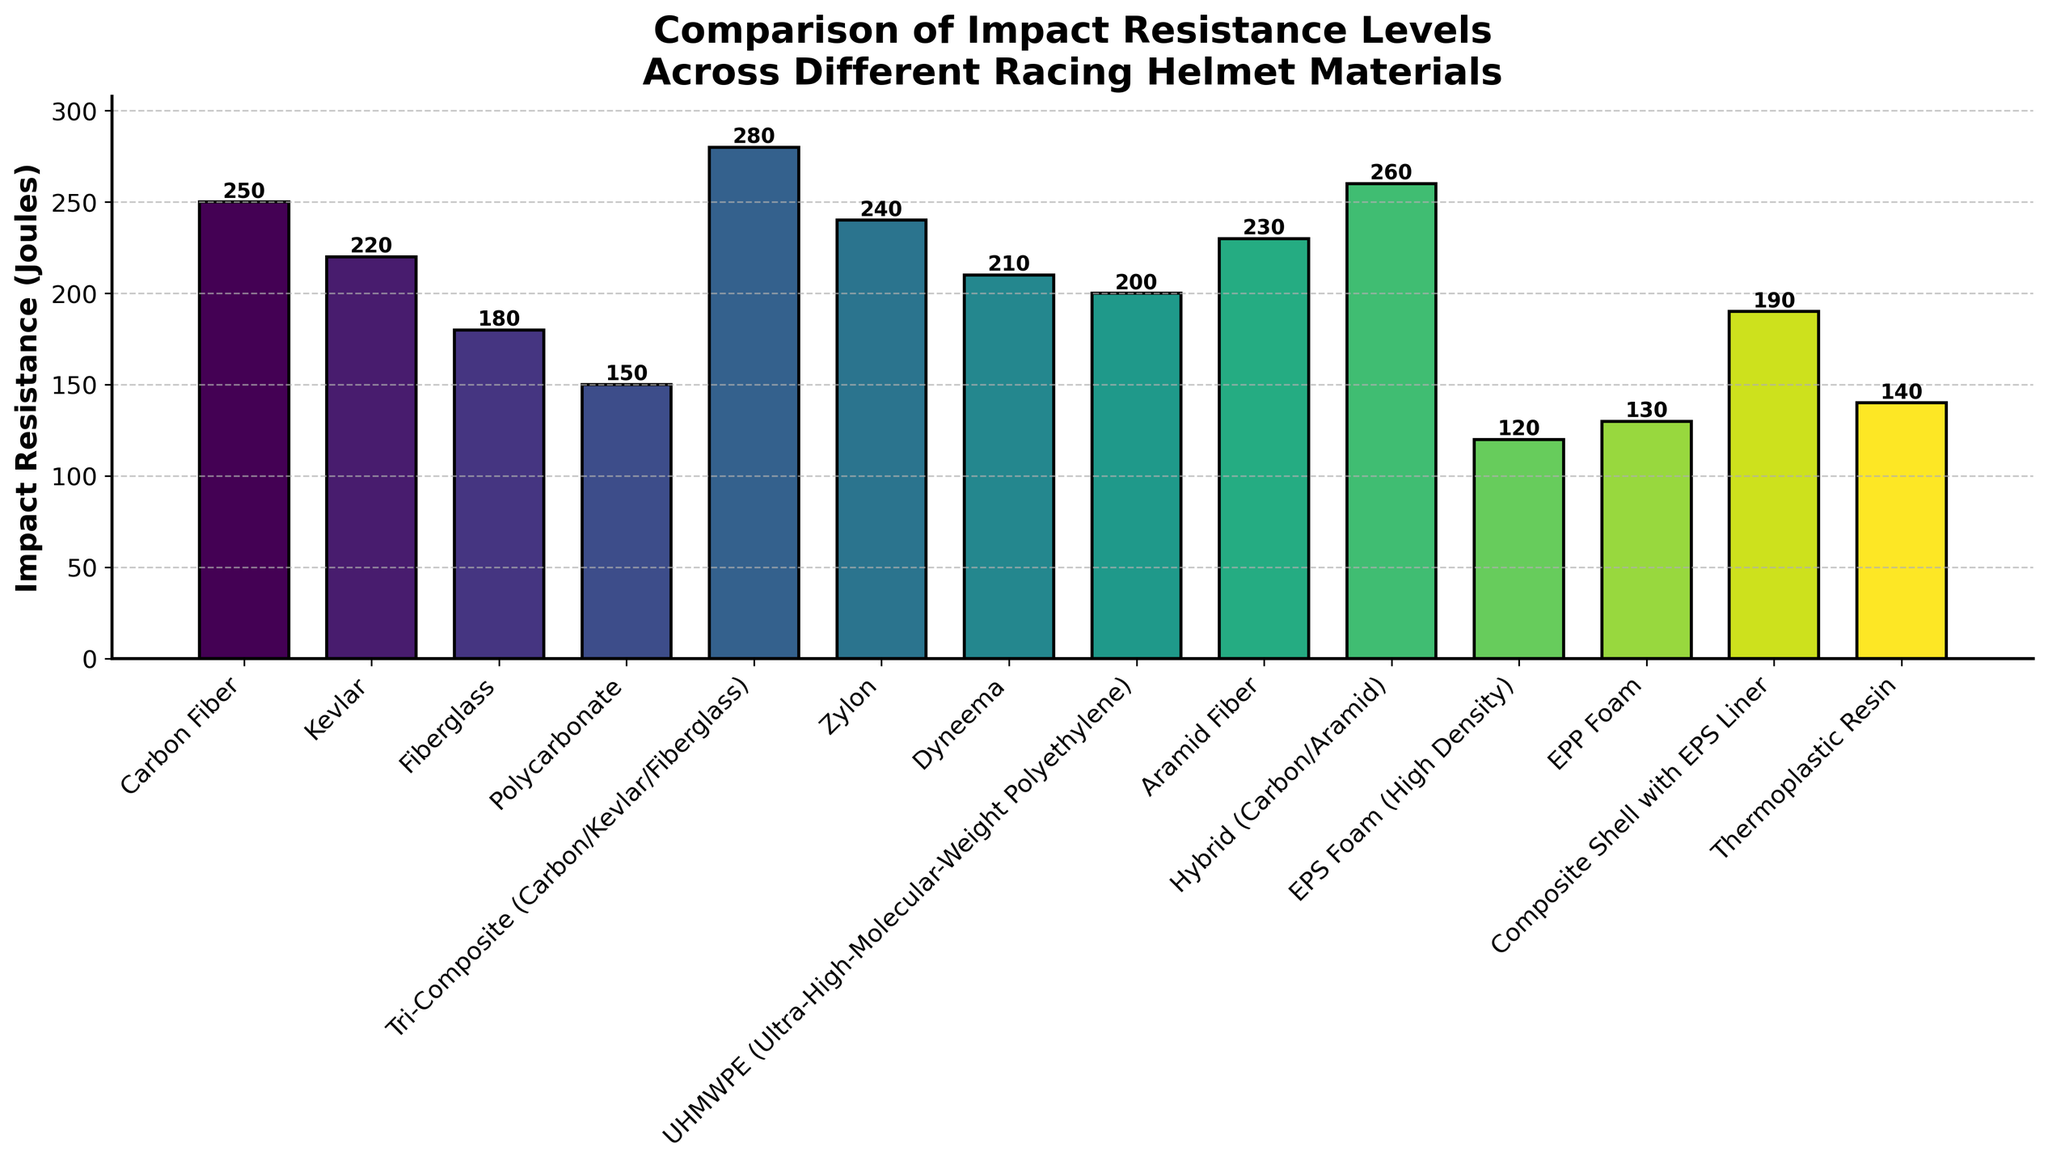Which material has the highest impact resistance? The bar chart shows different materials and their corresponding impact resistances. The tallest bar represents the highest impact resistance. Tri-Composite (Carbon/Kevlar/Fiberglass) has the tallest bar.
Answer: Tri-Composite (Carbon/Kevlar/Fiberglass) Which material has the lowest impact resistance? The bar chart has varying bar heights representing the impact resistance of each material. The shortest bar correlates to the lowest value. EPS Foam (High Density) has the shortest bar.
Answer: EPS Foam (High Density) What is the difference in impact resistance between Carbon Fiber and Kevlar? Locate the bars for Carbon Fiber and Kevlar. The heights correspond to 250 Joules and 220 Joules respectively. Calculate the difference: 250 - 220.
Answer: 30 Joules How does the impact resistance of Polycarbonate compare to Zylon? Identify the bars for Polycarbonate and Zylon. Polycarbonate is at 150 Joules, while Zylon is at 240 Joules. Zylon has a higher impact resistance than Polycarbonate.
Answer: Zylon is higher What is the average impact resistance of Kevlar, Fiberglass, and Polycarbonate? Aggregate the impact resistances of Kevlar (220 Joules), Fiberglass (180 Joules), and Polycarbonate (150 Joules). Sum these values (220 + 180 + 150 = 550) and divide by 3 to get the average.
Answer: 183.33 Joules Which material(s) have an impact resistance greater than 230 Joules? Identify all the bars whose height exceeds 230 Joules. These materials are Carbon Fiber (250 Joules), Tri-Composite (280 Joules), Zylon (240 Joules), and Hybrid (260 Joules).
Answer: Carbon Fiber, Tri-Composite (Carbon/Kevlar/Fiberglass), Zylon, Hybrid (Carbon/Aramid) How much more impact resistant is UHMWPE compared to Thermoplastic Resin? Locate the bars for UHMWPE (200 Joules) and Thermoplastic Resin (140 Joules). Subtract the impact resistance of Thermoplastic Resin from UHMWPE: 200 - 140.
Answer: 60 Joules What is the combined impact resistance of Aramid Fiber and Hybrid materials? Identify the bars representing Aramid Fiber (230 Joules) and Hybrid (260 Joules). Sum their values: 230 + 260.
Answer: 490 Joules What is the visual difference between the bar representing EPS Foam (High Density) and EPP Foam? The bar for EPS Foam (High Density) is shorter and reaches 120 Joules while EPP Foam is slightly taller reaching 130 Joules. The difference in height visually corresponds to their impact resistance values.
Answer: EPS Foam (High Density) is shorter than EPP Foam Which material shows a moderate impact resistance level but not among the highest performers? Identify a material that does not have the shortest nor the tallest bar but resides in a mid-range height, for instance, Dyneema with 210 Joules.
Answer: Dyneema 